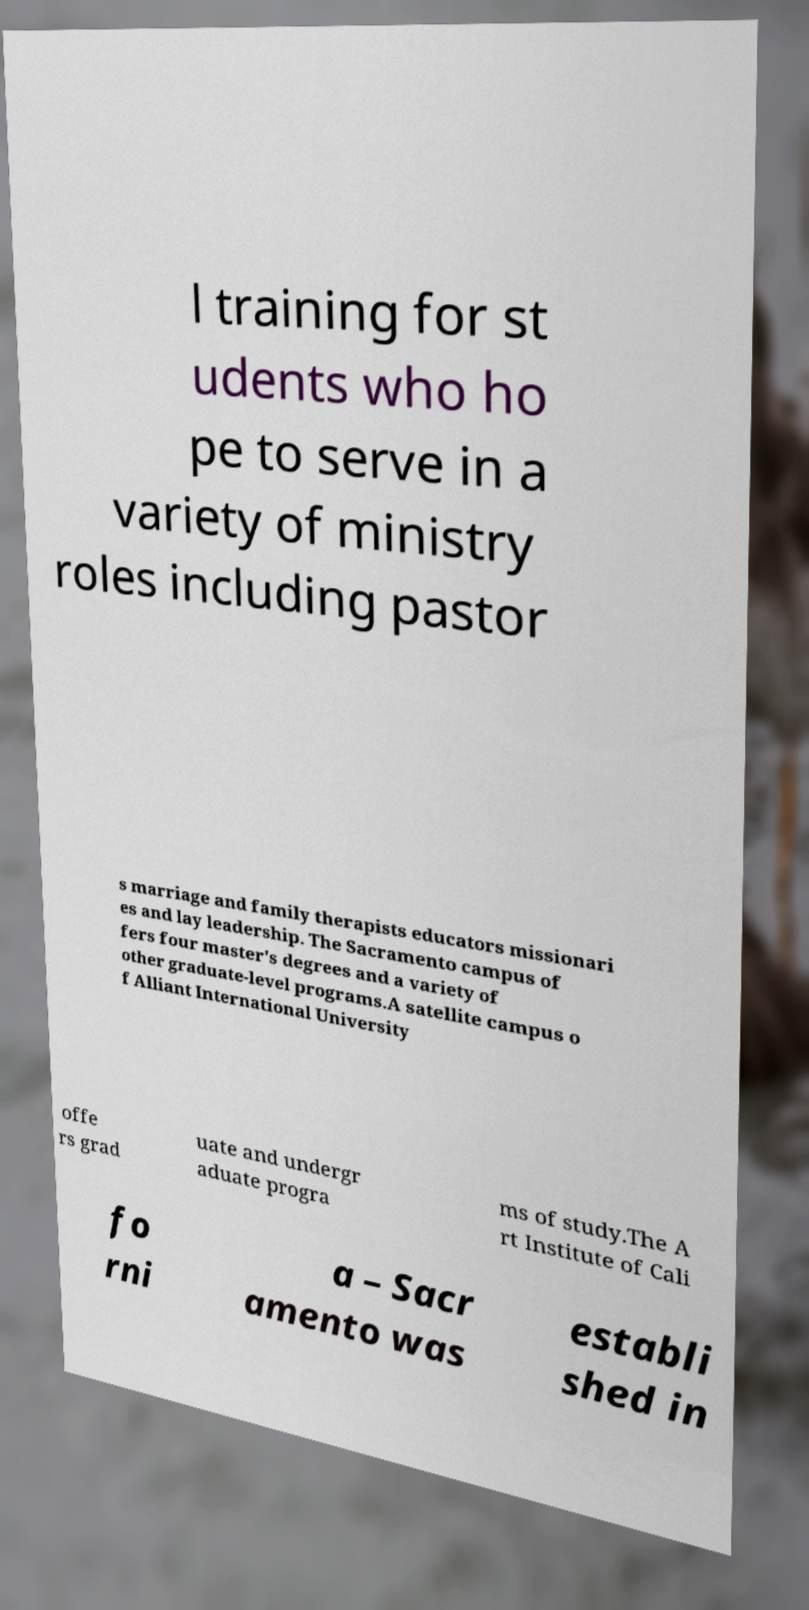What messages or text are displayed in this image? I need them in a readable, typed format. l training for st udents who ho pe to serve in a variety of ministry roles including pastor s marriage and family therapists educators missionari es and lay leadership. The Sacramento campus of fers four master's degrees and a variety of other graduate-level programs.A satellite campus o f Alliant International University offe rs grad uate and undergr aduate progra ms of study.The A rt Institute of Cali fo rni a – Sacr amento was establi shed in 